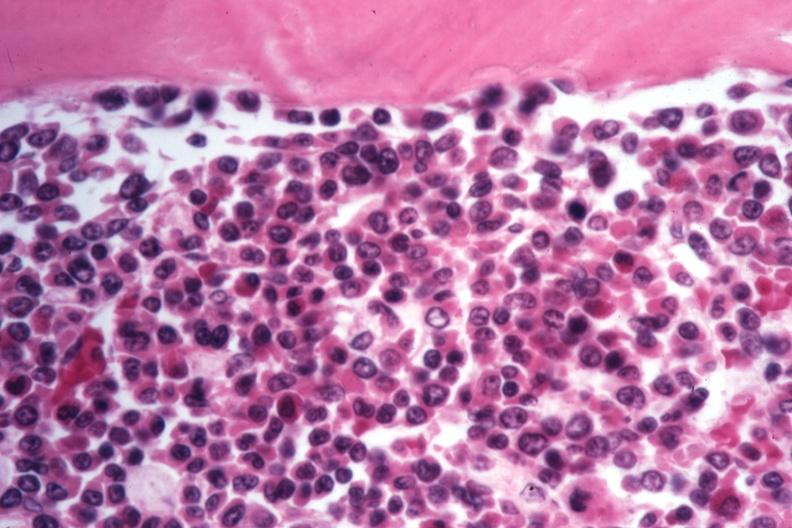what appears to be moving to blast crisis?
Answer the question using a single word or phrase. This cells 